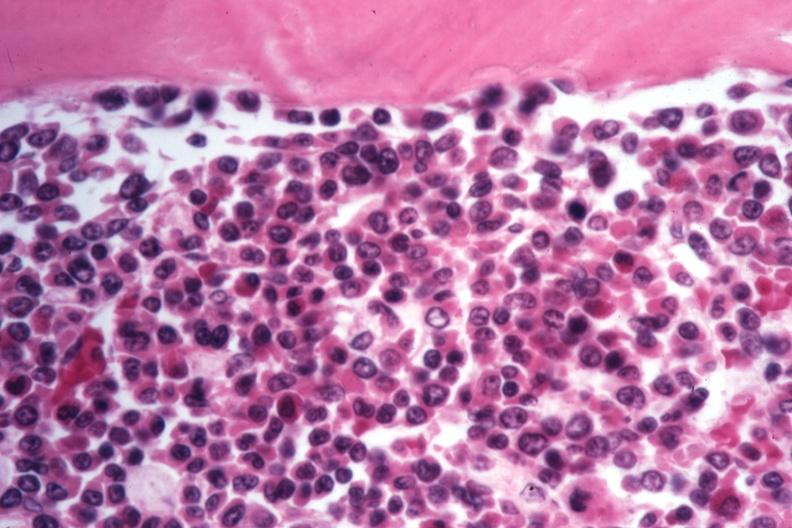what appears to be moving to blast crisis?
Answer the question using a single word or phrase. This cells 